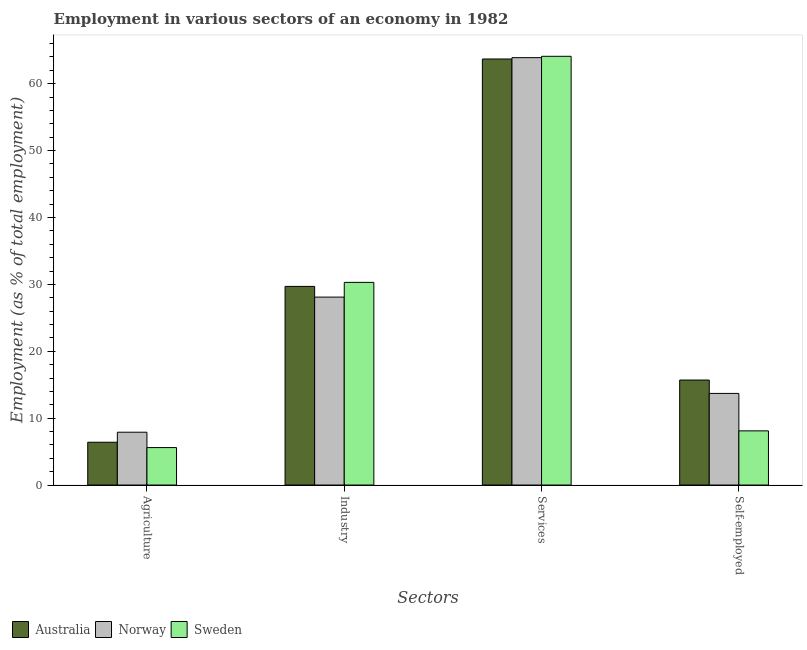How many different coloured bars are there?
Offer a very short reply. 3. How many bars are there on the 4th tick from the left?
Your response must be concise. 3. How many bars are there on the 2nd tick from the right?
Offer a very short reply. 3. What is the label of the 4th group of bars from the left?
Your answer should be very brief. Self-employed. What is the percentage of workers in agriculture in Norway?
Provide a short and direct response. 7.9. Across all countries, what is the maximum percentage of workers in services?
Your answer should be compact. 64.1. Across all countries, what is the minimum percentage of workers in services?
Keep it short and to the point. 63.7. What is the total percentage of workers in industry in the graph?
Offer a very short reply. 88.1. What is the difference between the percentage of workers in services in Australia and that in Norway?
Provide a short and direct response. -0.2. What is the difference between the percentage of workers in services in Norway and the percentage of workers in industry in Australia?
Your answer should be very brief. 34.2. What is the average percentage of workers in industry per country?
Provide a succinct answer. 29.37. What is the difference between the percentage of self employed workers and percentage of workers in services in Australia?
Your response must be concise. -48. What is the ratio of the percentage of workers in agriculture in Sweden to that in Australia?
Offer a very short reply. 0.87. What is the difference between the highest and the second highest percentage of workers in services?
Offer a very short reply. 0.2. What is the difference between the highest and the lowest percentage of self employed workers?
Ensure brevity in your answer.  7.6. Is the sum of the percentage of self employed workers in Norway and Australia greater than the maximum percentage of workers in agriculture across all countries?
Your response must be concise. Yes. Is it the case that in every country, the sum of the percentage of workers in industry and percentage of workers in agriculture is greater than the sum of percentage of workers in services and percentage of self employed workers?
Make the answer very short. Yes. What does the 3rd bar from the left in Industry represents?
Your answer should be compact. Sweden. How many bars are there?
Offer a terse response. 12. How many countries are there in the graph?
Ensure brevity in your answer.  3. Does the graph contain grids?
Keep it short and to the point. No. How many legend labels are there?
Make the answer very short. 3. How are the legend labels stacked?
Provide a succinct answer. Horizontal. What is the title of the graph?
Keep it short and to the point. Employment in various sectors of an economy in 1982. Does "Ireland" appear as one of the legend labels in the graph?
Offer a terse response. No. What is the label or title of the X-axis?
Your response must be concise. Sectors. What is the label or title of the Y-axis?
Provide a short and direct response. Employment (as % of total employment). What is the Employment (as % of total employment) of Australia in Agriculture?
Your answer should be very brief. 6.4. What is the Employment (as % of total employment) of Norway in Agriculture?
Give a very brief answer. 7.9. What is the Employment (as % of total employment) of Sweden in Agriculture?
Ensure brevity in your answer.  5.6. What is the Employment (as % of total employment) in Australia in Industry?
Offer a terse response. 29.7. What is the Employment (as % of total employment) in Norway in Industry?
Make the answer very short. 28.1. What is the Employment (as % of total employment) of Sweden in Industry?
Provide a short and direct response. 30.3. What is the Employment (as % of total employment) of Australia in Services?
Provide a short and direct response. 63.7. What is the Employment (as % of total employment) of Norway in Services?
Give a very brief answer. 63.9. What is the Employment (as % of total employment) of Sweden in Services?
Keep it short and to the point. 64.1. What is the Employment (as % of total employment) in Australia in Self-employed?
Give a very brief answer. 15.7. What is the Employment (as % of total employment) of Norway in Self-employed?
Provide a short and direct response. 13.7. What is the Employment (as % of total employment) of Sweden in Self-employed?
Keep it short and to the point. 8.1. Across all Sectors, what is the maximum Employment (as % of total employment) of Australia?
Provide a short and direct response. 63.7. Across all Sectors, what is the maximum Employment (as % of total employment) of Norway?
Provide a succinct answer. 63.9. Across all Sectors, what is the maximum Employment (as % of total employment) of Sweden?
Make the answer very short. 64.1. Across all Sectors, what is the minimum Employment (as % of total employment) in Australia?
Make the answer very short. 6.4. Across all Sectors, what is the minimum Employment (as % of total employment) in Norway?
Offer a terse response. 7.9. Across all Sectors, what is the minimum Employment (as % of total employment) of Sweden?
Ensure brevity in your answer.  5.6. What is the total Employment (as % of total employment) in Australia in the graph?
Offer a terse response. 115.5. What is the total Employment (as % of total employment) in Norway in the graph?
Provide a succinct answer. 113.6. What is the total Employment (as % of total employment) of Sweden in the graph?
Your answer should be compact. 108.1. What is the difference between the Employment (as % of total employment) in Australia in Agriculture and that in Industry?
Offer a very short reply. -23.3. What is the difference between the Employment (as % of total employment) of Norway in Agriculture and that in Industry?
Offer a very short reply. -20.2. What is the difference between the Employment (as % of total employment) in Sweden in Agriculture and that in Industry?
Keep it short and to the point. -24.7. What is the difference between the Employment (as % of total employment) of Australia in Agriculture and that in Services?
Make the answer very short. -57.3. What is the difference between the Employment (as % of total employment) of Norway in Agriculture and that in Services?
Provide a succinct answer. -56. What is the difference between the Employment (as % of total employment) in Sweden in Agriculture and that in Services?
Offer a very short reply. -58.5. What is the difference between the Employment (as % of total employment) in Australia in Agriculture and that in Self-employed?
Your response must be concise. -9.3. What is the difference between the Employment (as % of total employment) in Australia in Industry and that in Services?
Your answer should be compact. -34. What is the difference between the Employment (as % of total employment) in Norway in Industry and that in Services?
Offer a very short reply. -35.8. What is the difference between the Employment (as % of total employment) of Sweden in Industry and that in Services?
Offer a very short reply. -33.8. What is the difference between the Employment (as % of total employment) of Australia in Services and that in Self-employed?
Your response must be concise. 48. What is the difference between the Employment (as % of total employment) of Norway in Services and that in Self-employed?
Make the answer very short. 50.2. What is the difference between the Employment (as % of total employment) of Australia in Agriculture and the Employment (as % of total employment) of Norway in Industry?
Your answer should be compact. -21.7. What is the difference between the Employment (as % of total employment) of Australia in Agriculture and the Employment (as % of total employment) of Sweden in Industry?
Provide a short and direct response. -23.9. What is the difference between the Employment (as % of total employment) of Norway in Agriculture and the Employment (as % of total employment) of Sweden in Industry?
Offer a terse response. -22.4. What is the difference between the Employment (as % of total employment) in Australia in Agriculture and the Employment (as % of total employment) in Norway in Services?
Provide a short and direct response. -57.5. What is the difference between the Employment (as % of total employment) in Australia in Agriculture and the Employment (as % of total employment) in Sweden in Services?
Provide a short and direct response. -57.7. What is the difference between the Employment (as % of total employment) of Norway in Agriculture and the Employment (as % of total employment) of Sweden in Services?
Your response must be concise. -56.2. What is the difference between the Employment (as % of total employment) of Australia in Agriculture and the Employment (as % of total employment) of Norway in Self-employed?
Ensure brevity in your answer.  -7.3. What is the difference between the Employment (as % of total employment) in Norway in Agriculture and the Employment (as % of total employment) in Sweden in Self-employed?
Provide a short and direct response. -0.2. What is the difference between the Employment (as % of total employment) in Australia in Industry and the Employment (as % of total employment) in Norway in Services?
Your response must be concise. -34.2. What is the difference between the Employment (as % of total employment) in Australia in Industry and the Employment (as % of total employment) in Sweden in Services?
Keep it short and to the point. -34.4. What is the difference between the Employment (as % of total employment) of Norway in Industry and the Employment (as % of total employment) of Sweden in Services?
Offer a very short reply. -36. What is the difference between the Employment (as % of total employment) of Australia in Industry and the Employment (as % of total employment) of Norway in Self-employed?
Your answer should be very brief. 16. What is the difference between the Employment (as % of total employment) in Australia in Industry and the Employment (as % of total employment) in Sweden in Self-employed?
Offer a terse response. 21.6. What is the difference between the Employment (as % of total employment) in Norway in Industry and the Employment (as % of total employment) in Sweden in Self-employed?
Provide a succinct answer. 20. What is the difference between the Employment (as % of total employment) in Australia in Services and the Employment (as % of total employment) in Sweden in Self-employed?
Your answer should be very brief. 55.6. What is the difference between the Employment (as % of total employment) in Norway in Services and the Employment (as % of total employment) in Sweden in Self-employed?
Provide a short and direct response. 55.8. What is the average Employment (as % of total employment) in Australia per Sectors?
Provide a succinct answer. 28.88. What is the average Employment (as % of total employment) in Norway per Sectors?
Provide a succinct answer. 28.4. What is the average Employment (as % of total employment) of Sweden per Sectors?
Your answer should be compact. 27.02. What is the difference between the Employment (as % of total employment) of Australia and Employment (as % of total employment) of Norway in Industry?
Offer a terse response. 1.6. What is the difference between the Employment (as % of total employment) of Norway and Employment (as % of total employment) of Sweden in Self-employed?
Provide a succinct answer. 5.6. What is the ratio of the Employment (as % of total employment) of Australia in Agriculture to that in Industry?
Make the answer very short. 0.22. What is the ratio of the Employment (as % of total employment) in Norway in Agriculture to that in Industry?
Ensure brevity in your answer.  0.28. What is the ratio of the Employment (as % of total employment) in Sweden in Agriculture to that in Industry?
Provide a short and direct response. 0.18. What is the ratio of the Employment (as % of total employment) of Australia in Agriculture to that in Services?
Your response must be concise. 0.1. What is the ratio of the Employment (as % of total employment) in Norway in Agriculture to that in Services?
Make the answer very short. 0.12. What is the ratio of the Employment (as % of total employment) of Sweden in Agriculture to that in Services?
Make the answer very short. 0.09. What is the ratio of the Employment (as % of total employment) in Australia in Agriculture to that in Self-employed?
Ensure brevity in your answer.  0.41. What is the ratio of the Employment (as % of total employment) of Norway in Agriculture to that in Self-employed?
Give a very brief answer. 0.58. What is the ratio of the Employment (as % of total employment) of Sweden in Agriculture to that in Self-employed?
Provide a short and direct response. 0.69. What is the ratio of the Employment (as % of total employment) in Australia in Industry to that in Services?
Provide a succinct answer. 0.47. What is the ratio of the Employment (as % of total employment) of Norway in Industry to that in Services?
Provide a succinct answer. 0.44. What is the ratio of the Employment (as % of total employment) in Sweden in Industry to that in Services?
Ensure brevity in your answer.  0.47. What is the ratio of the Employment (as % of total employment) in Australia in Industry to that in Self-employed?
Give a very brief answer. 1.89. What is the ratio of the Employment (as % of total employment) of Norway in Industry to that in Self-employed?
Your answer should be compact. 2.05. What is the ratio of the Employment (as % of total employment) of Sweden in Industry to that in Self-employed?
Give a very brief answer. 3.74. What is the ratio of the Employment (as % of total employment) in Australia in Services to that in Self-employed?
Ensure brevity in your answer.  4.06. What is the ratio of the Employment (as % of total employment) in Norway in Services to that in Self-employed?
Ensure brevity in your answer.  4.66. What is the ratio of the Employment (as % of total employment) of Sweden in Services to that in Self-employed?
Provide a succinct answer. 7.91. What is the difference between the highest and the second highest Employment (as % of total employment) in Australia?
Your response must be concise. 34. What is the difference between the highest and the second highest Employment (as % of total employment) in Norway?
Provide a succinct answer. 35.8. What is the difference between the highest and the second highest Employment (as % of total employment) of Sweden?
Keep it short and to the point. 33.8. What is the difference between the highest and the lowest Employment (as % of total employment) in Australia?
Keep it short and to the point. 57.3. What is the difference between the highest and the lowest Employment (as % of total employment) of Norway?
Offer a terse response. 56. What is the difference between the highest and the lowest Employment (as % of total employment) in Sweden?
Your response must be concise. 58.5. 